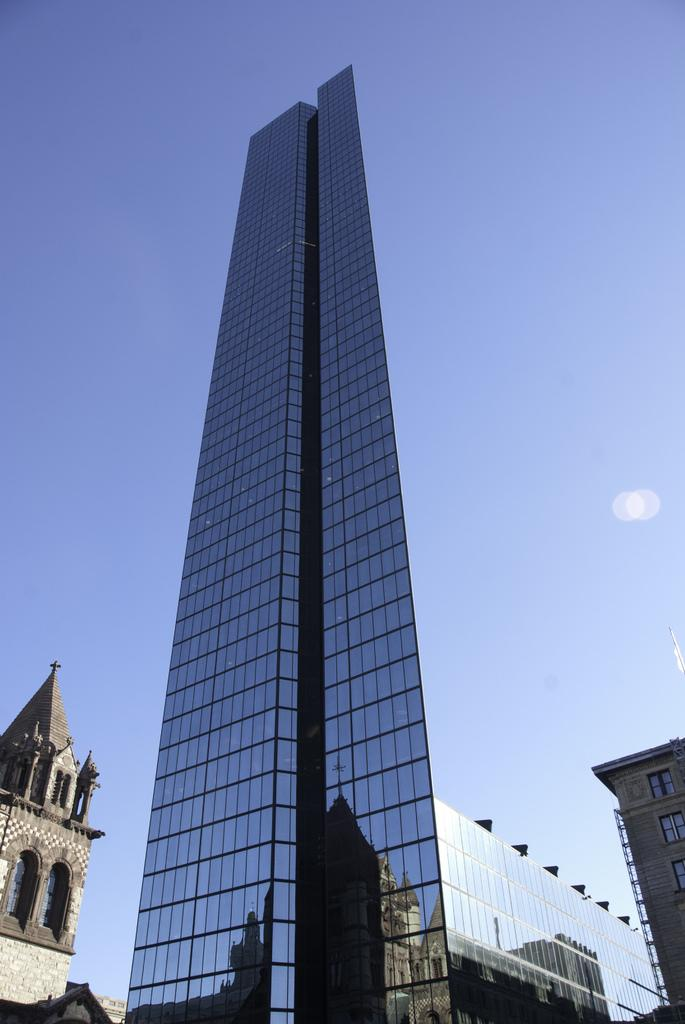What type of structures can be seen in the image? There are buildings in the image. What part of the natural environment is visible in the image? The sky is visible in the background of the image. What type of tool is being used by the authority figure in the image? There is no authority figure or tool present in the image. What time is it according to the watch in the image? There is no watch present in the image. 